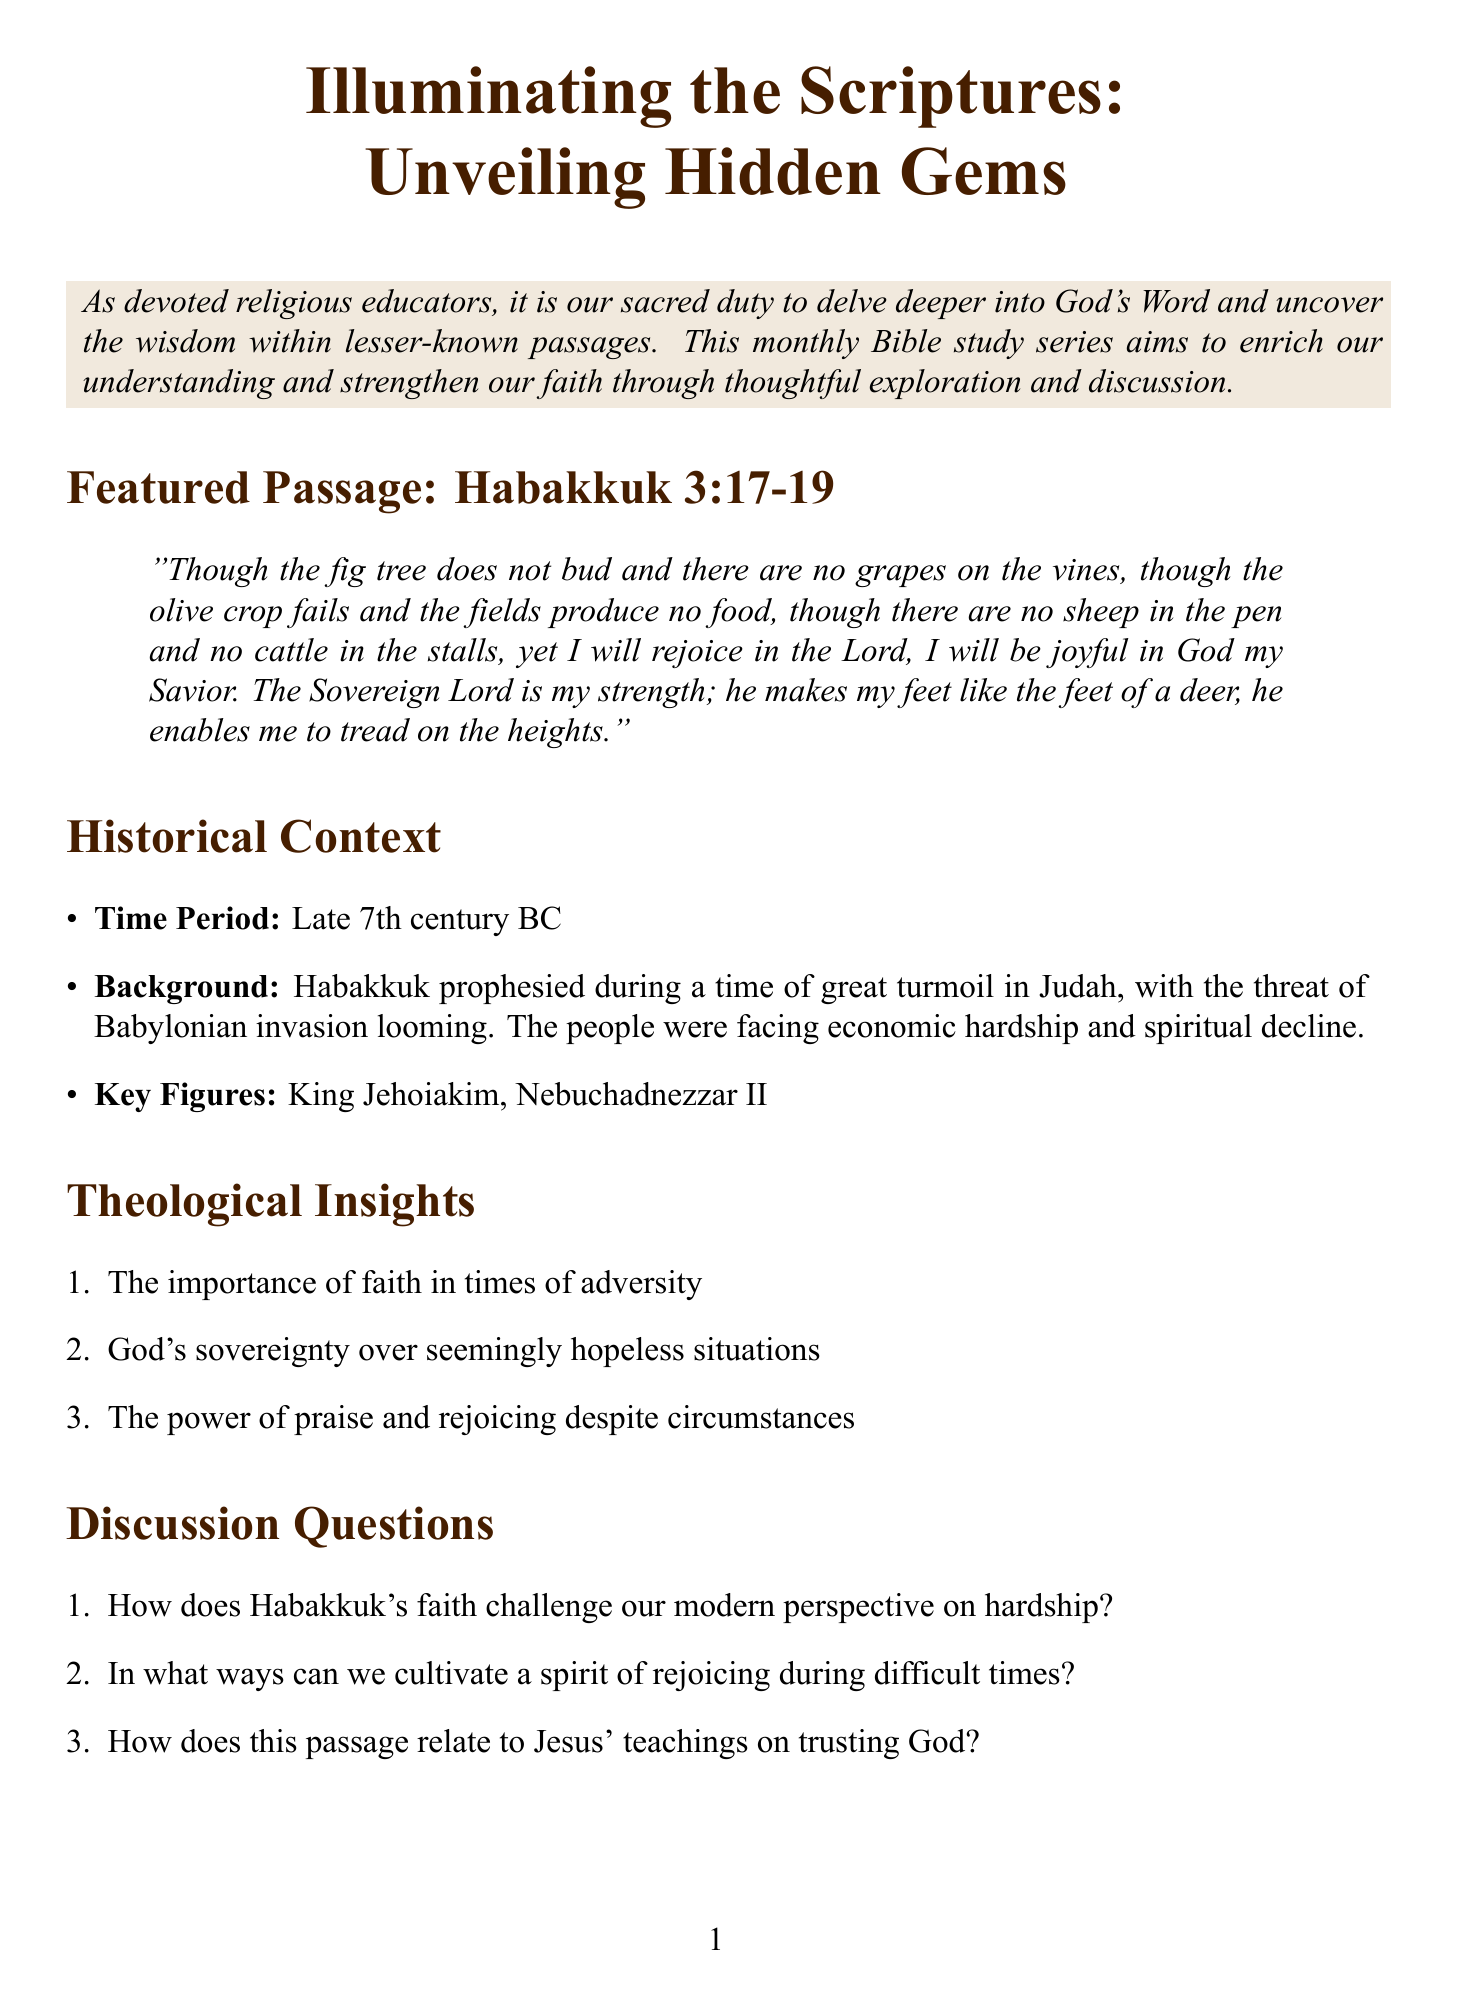What is the title of the newsletter? The title is the main heading that represents the content of the document.
Answer: Illuminating the Scriptures: Unveiling Hidden Gems Which book of the Bible is featured in this study? The featured passage provides specific information about the book being discussed.
Answer: Habakkuk What chapter and verses are highlighted in Habakkuk? This is obtained from the section specifying the featured passage.
Answer: 3:17-19 Who prophesied during a time of great turmoil in Judah? The historical context section identifies the prophet associated with the time mentioned.
Answer: Habakkuk What period is indicated in the historical context? This information is specified in the historical context of the document.
Answer: Late 7th century BC Name one key figure mentioned in the background. The background information provides specific names of figures connected to the context.
Answer: King Jehoiakim What is one of the theological insights discussed? The theological insights section lists key concepts derived from the featured passage.
Answer: The importance of faith in times of adversity How many discussion questions are provided? This relates to the enumeration found in the discussion questions section.
Answer: Three What type of resources are included in the additional resources section? The additional resources section lists types of materials available for further study.
Answer: Commentaries and online study tools What is the closing prayer focused on? The closing prayer summarizes the plea being made in the document.
Answer: Trust in God's sovereignty 